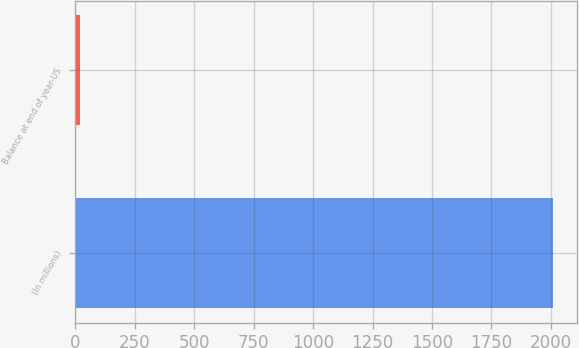<chart> <loc_0><loc_0><loc_500><loc_500><bar_chart><fcel>(In millions)<fcel>Balance at end of year-US<nl><fcel>2008<fcel>18<nl></chart> 